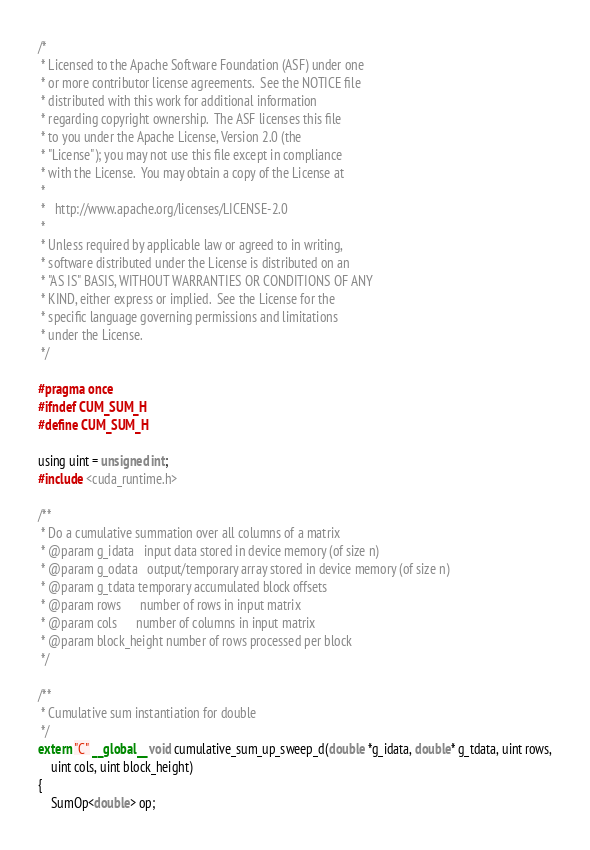Convert code to text. <code><loc_0><loc_0><loc_500><loc_500><_Cuda_>/*
 * Licensed to the Apache Software Foundation (ASF) under one
 * or more contributor license agreements.  See the NOTICE file
 * distributed with this work for additional information
 * regarding copyright ownership.  The ASF licenses this file
 * to you under the Apache License, Version 2.0 (the
 * "License"); you may not use this file except in compliance
 * with the License.  You may obtain a copy of the License at
 *
 *   http://www.apache.org/licenses/LICENSE-2.0
 *
 * Unless required by applicable law or agreed to in writing,
 * software distributed under the License is distributed on an
 * "AS IS" BASIS, WITHOUT WARRANTIES OR CONDITIONS OF ANY
 * KIND, either express or implied.  See the License for the
 * specific language governing permissions and limitations
 * under the License.
 */

#pragma once
#ifndef CUM_SUM_H
#define CUM_SUM_H

using uint = unsigned int;
#include <cuda_runtime.h>

/**
 * Do a cumulative summation over all columns of a matrix
 * @param g_idata   input data stored in device memory (of size n)
 * @param g_odata   output/temporary array stored in device memory (of size n)
 * @param g_tdata temporary accumulated block offsets
 * @param rows      number of rows in input matrix
 * @param cols      number of columns in input matrix
 * @param block_height number of rows processed per block
 */

/**
 * Cumulative sum instantiation for double
 */
extern "C" __global__ void cumulative_sum_up_sweep_d(double *g_idata, double* g_tdata, uint rows,
    uint cols, uint block_height)
{
	SumOp<double> op;</code> 